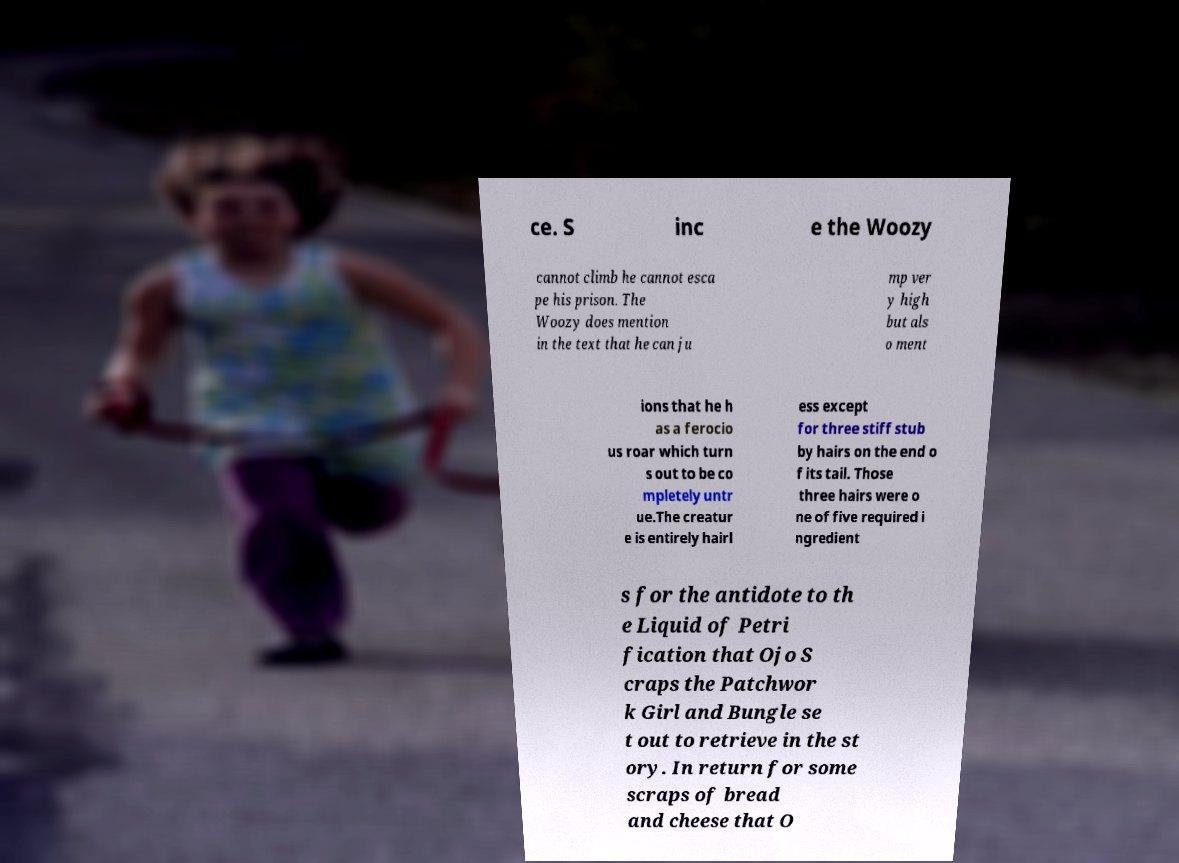For documentation purposes, I need the text within this image transcribed. Could you provide that? ce. S inc e the Woozy cannot climb he cannot esca pe his prison. The Woozy does mention in the text that he can ju mp ver y high but als o ment ions that he h as a ferocio us roar which turn s out to be co mpletely untr ue.The creatur e is entirely hairl ess except for three stiff stub by hairs on the end o f its tail. Those three hairs were o ne of five required i ngredient s for the antidote to th e Liquid of Petri fication that Ojo S craps the Patchwor k Girl and Bungle se t out to retrieve in the st ory. In return for some scraps of bread and cheese that O 